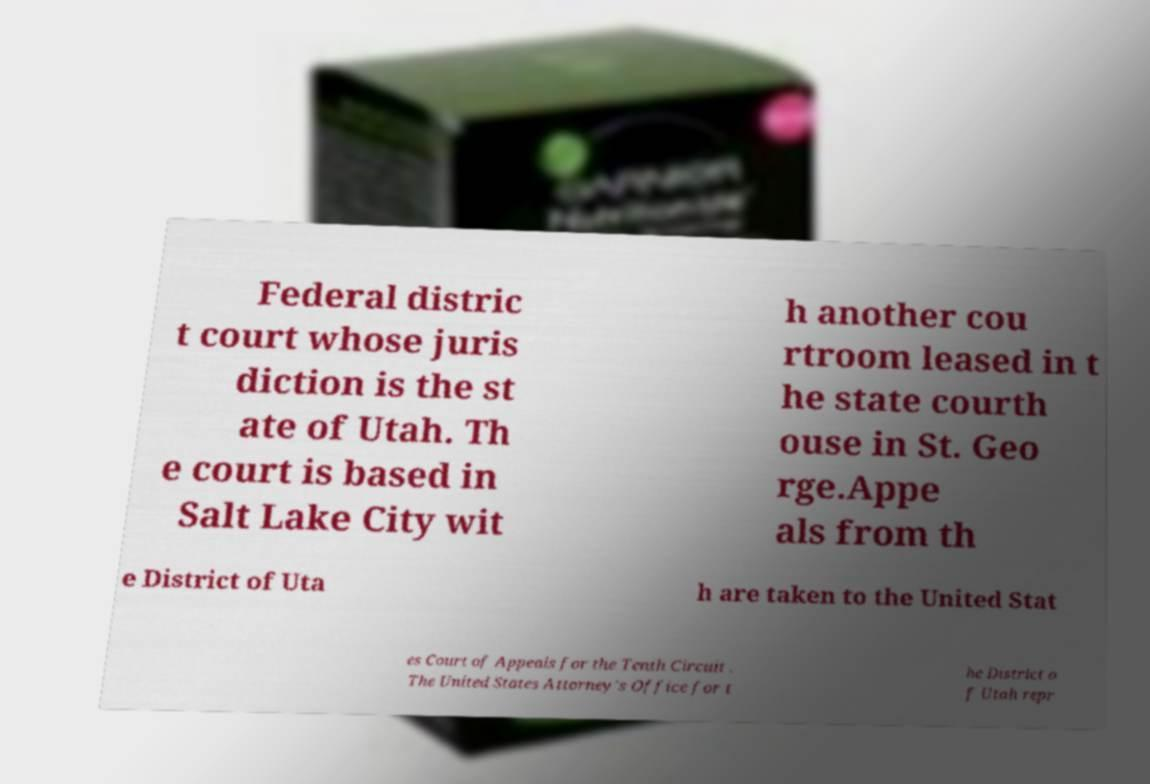There's text embedded in this image that I need extracted. Can you transcribe it verbatim? Federal distric t court whose juris diction is the st ate of Utah. Th e court is based in Salt Lake City wit h another cou rtroom leased in t he state courth ouse in St. Geo rge.Appe als from th e District of Uta h are taken to the United Stat es Court of Appeals for the Tenth Circuit . The United States Attorney's Office for t he District o f Utah repr 